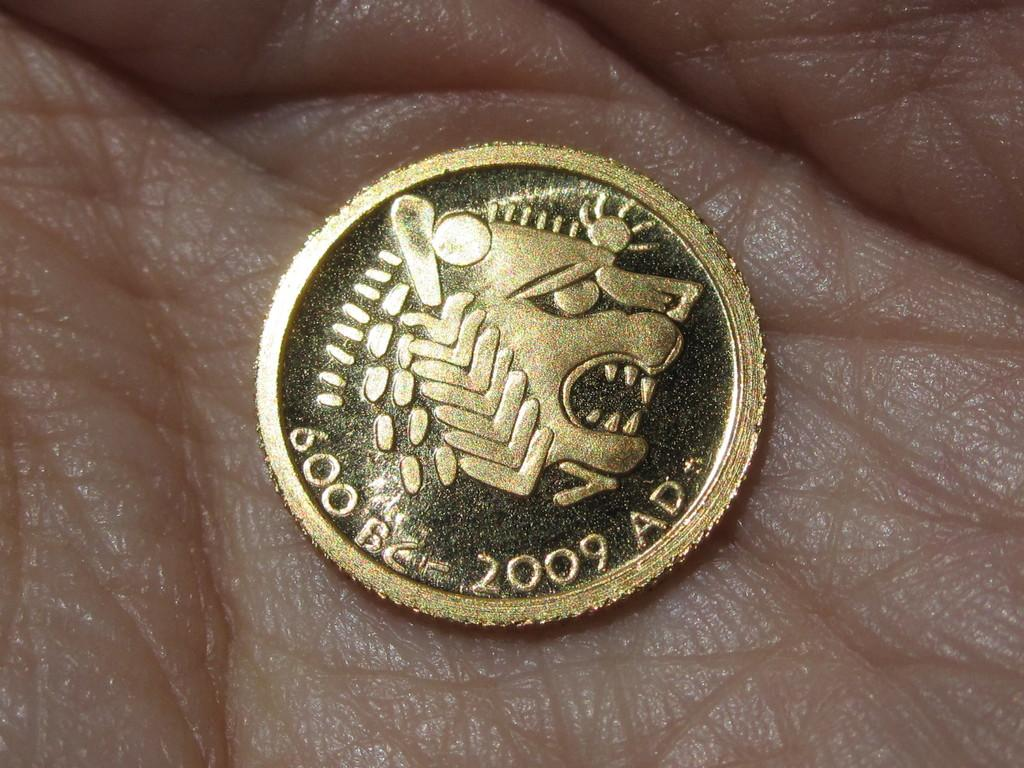<image>
Create a compact narrative representing the image presented. A hand holds a coin that reads 600 BC and 2009 AD. 